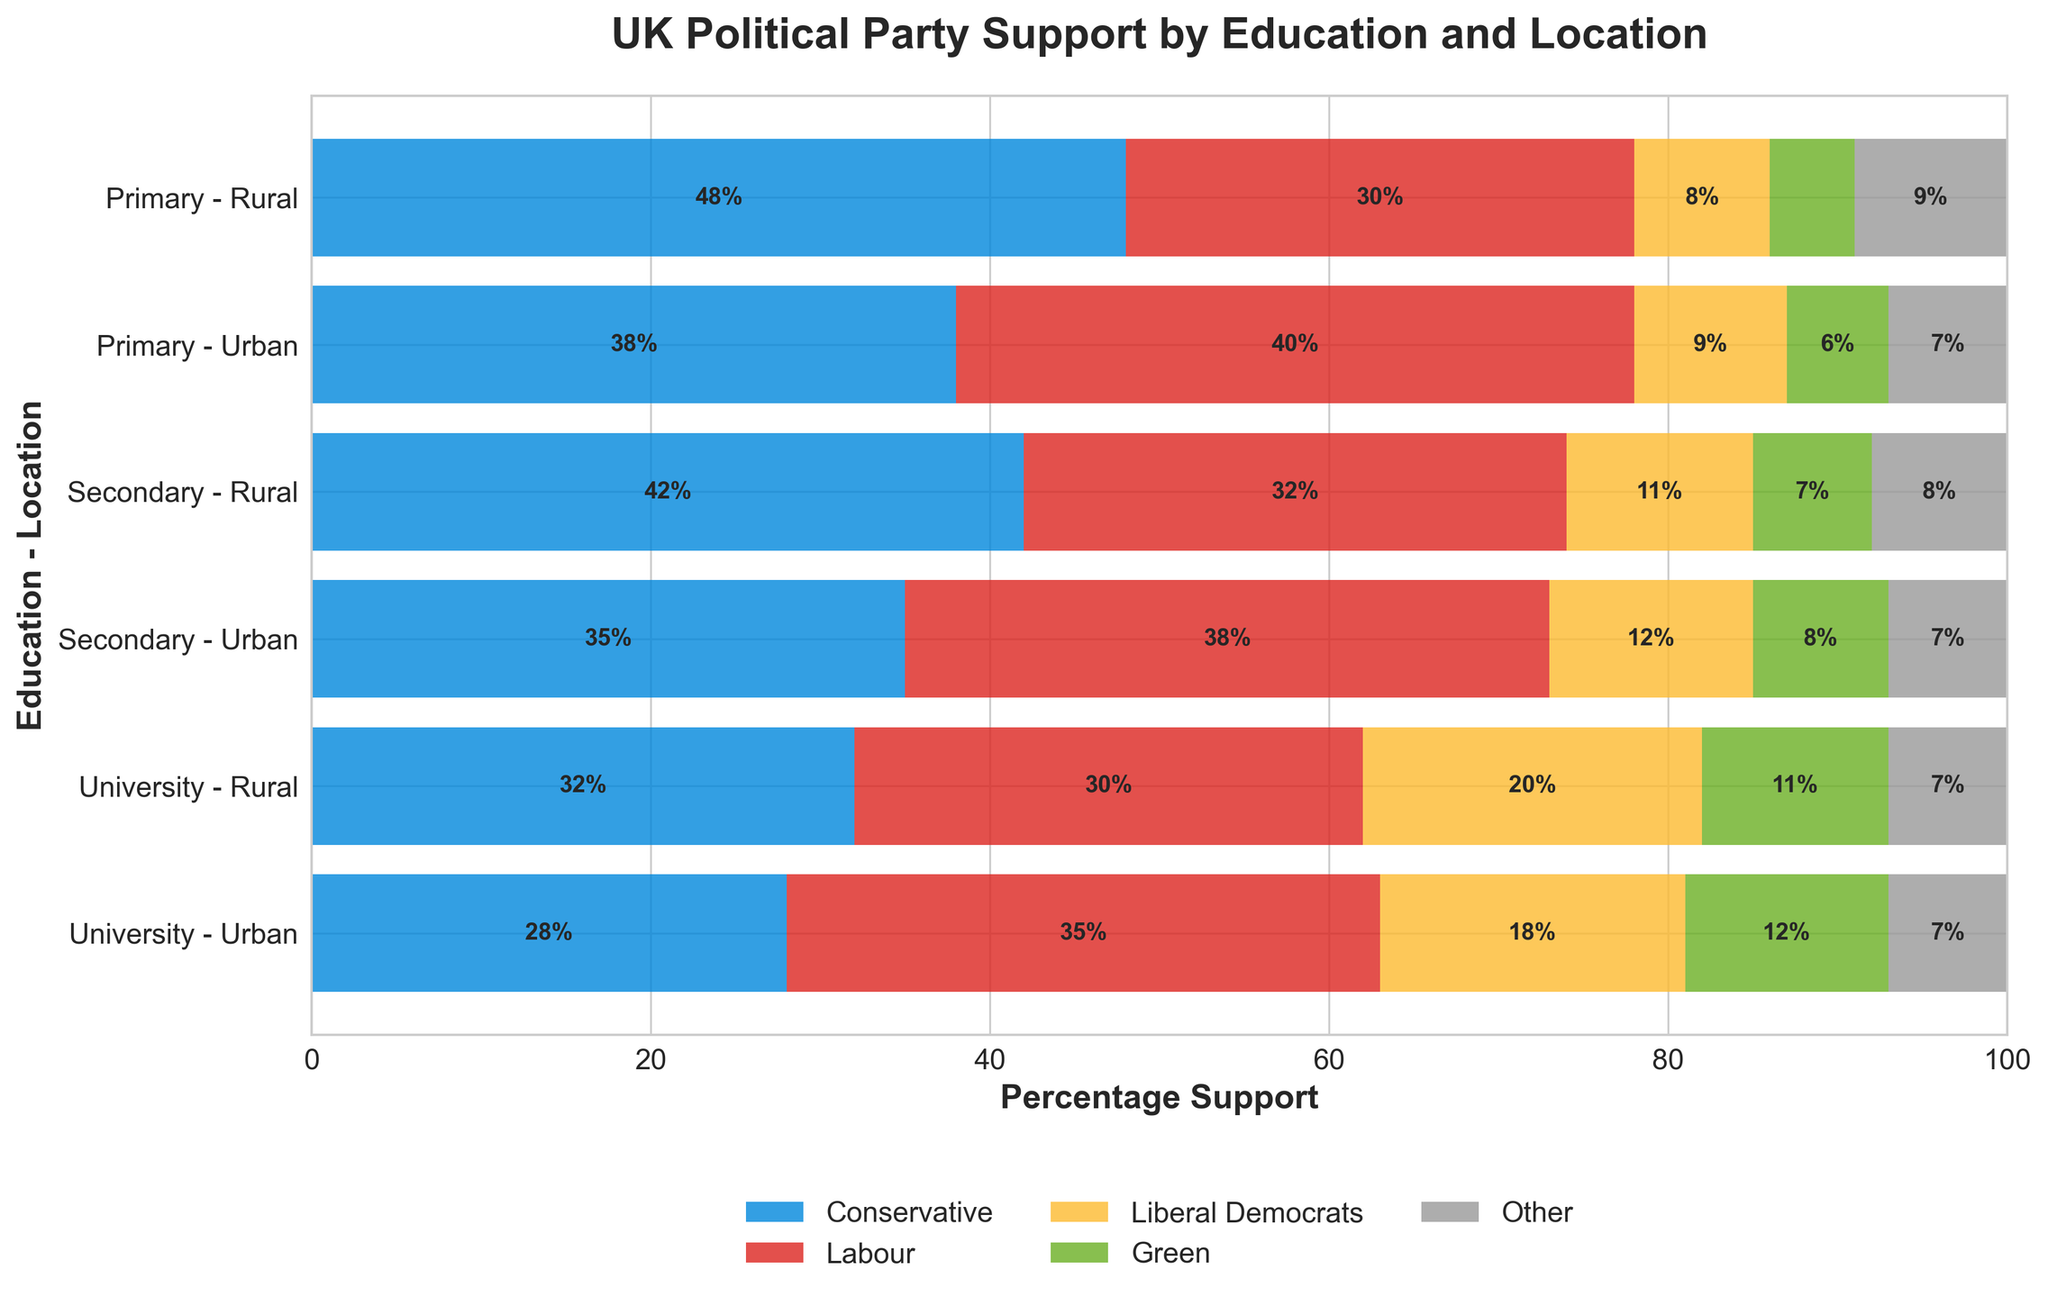What's the title of the figure? The title is displayed at the top center of the figure and reads "UK Political Party Support by Education and Location".
Answer: UK Political Party Support by Education and Location Which political party has the highest support among people with only primary education living in rural areas? Look at the bar representing "Primary - Rural". The largest segment in this bar is for the Conservative party.
Answer: Conservative How does Labour support compare between people with secondary education in urban areas and people with secondary education in rural areas? Look at the bars for "Secondary - Urban" and "Secondary - Rural". Labour support in urban areas is higher (38%) than in rural areas (32%).
Answer: Higher in urban areas What is the combined percentage of support for Green and Liberal Democrats among people with university education in urban areas? Add the percentages for Green (12%) and Liberal Democrats (18%) from the "University - Urban" bar.
Answer: 30% Which education and location group shows the greatest support for the Conservative party? Compare the segments representing Conservative support across all bars. The largest segment is for "Primary - Rural" with 48%.
Answer: Primary - Rural Compare the support for Labour and Green parties among people with university education in rural areas? Look at the "University - Rural" bar and compare the segments for Labour (30%) and Green (11%). Labour has higher support than Green.
Answer: Higher for Labour What is the total support for the Labour party among all education levels in urban areas? Sum Labour support in "Primary - Urban" (40%), "Secondary - Urban" (38%), and "University - Urban" (35%).
Answer: 113% Are there any groups where the support for Other parties is higher than 9%? Look through each bar's Other segment; only the "Primary - Rural" group shows 9%.
Answer: No What is the percentage difference in Conservative support between university-educated individuals in urban and rural areas? Subtract Conservative support in "University - Urban" (28%) from "University - Rural" (32%).
Answer: 4% Which group shows the smallest difference in support between the Conservative and Labour parties? Find the bar where the difference between Conservative and Labour support is the smallest. "University - Rural" has Conservative at 32% and Labour at 30%, a difference of 2%.
Answer: University - Rural 